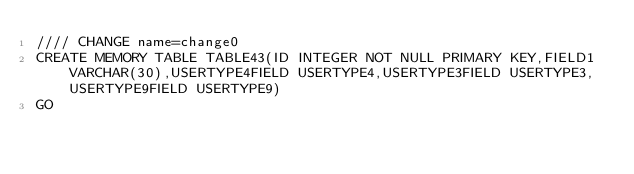<code> <loc_0><loc_0><loc_500><loc_500><_SQL_>//// CHANGE name=change0
CREATE MEMORY TABLE TABLE43(ID INTEGER NOT NULL PRIMARY KEY,FIELD1 VARCHAR(30),USERTYPE4FIELD USERTYPE4,USERTYPE3FIELD USERTYPE3,USERTYPE9FIELD USERTYPE9)
GO
</code> 